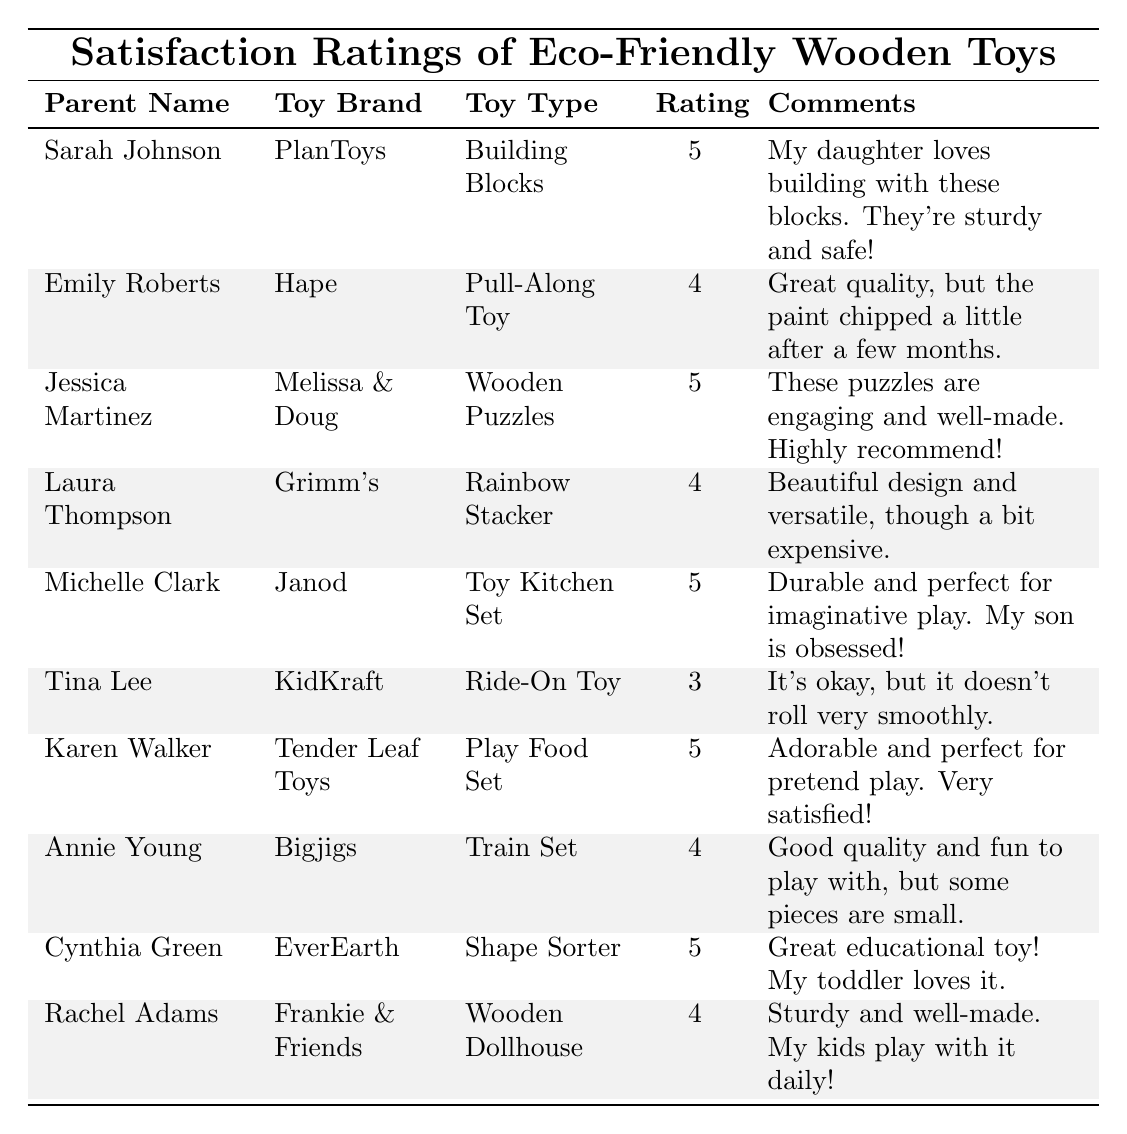What is the highest satisfaction rating given by a parent? The highest rating in the table is 5, given by Sarah Johnson, Jessica Martinez, Michelle Clark, Karen Walker, and Cynthia Green.
Answer: 5 How many toys received a satisfaction rating of 4? The toys rated 4 are the Pull-Along Toy, Rainbow Stacker, Train Set, and Wooden Dollhouse. There are 4 toys rated at this level.
Answer: 4 Is there any toy that received a rating of 3? Yes, the Ride-On Toy received a satisfaction rating of 3.
Answer: Yes Which toy type has the highest satisfaction rating and what is that rating? The Building Blocks, Wooden Puzzles, Toy Kitchen Set, Play Food Set, and Shape Sorter all received a rating of 5, which is the highest.
Answer: Building Blocks, Wooden Puzzles, Toy Kitchen Set, Play Food Set, Shape Sorter - 5 What is the average satisfaction rating of all toys listed? To find the average, we sum the ratings (5+4+5+4+5+3+5+4+5+4) = 49. Then we divide by the number of ratings (10), which gives us 49/10 = 4.9.
Answer: 4.9 Which parent commented that their child loves the toy they bought? Sarah Johnson mentioned that her daughter loves building with the blocks.
Answer: Sarah Johnson How many parents gave a satisfaction rating of 5 and also commented positively about the toy? The parents who rated 5 and commented positively are Sarah Johnson, Jessica Martinez, Michelle Clark, Karen Walker, and Cynthia Green, totaling 5 parents.
Answer: 5 Did the Toy Kitchen Set receive any negative comments from the parent? No, the comment for the Toy Kitchen Set was entirely positive about its durability and imaginative play.
Answer: No Which toy brand appears most frequently in the table? The toy brands mentioned are PlanToys, Hape, Melissa & Doug, Grimm's, Janod, KidKraft, Tender Leaf Toys, Bigjigs, EverEarth, and Frankie & Friends. Each brand appears only once.
Answer: None (all brands appear once) What did the parent with the lowest satisfaction rating (3) say about their toy? Tina Lee noted that the Ride-On Toy "It's okay, but it doesn't roll very smoothly."
Answer: It doesn't roll very smoothly If a parent wanted a high-quality toy, which brands should they consider based on the ratings? Parents should consider PlanToys, Melissa & Doug, Janod, Tender Leaf Toys, and EverEarth as these brands received ratings of 5.
Answer: PlanToys, Melissa & Doug, Janod, Tender Leaf Toys, EverEarth 